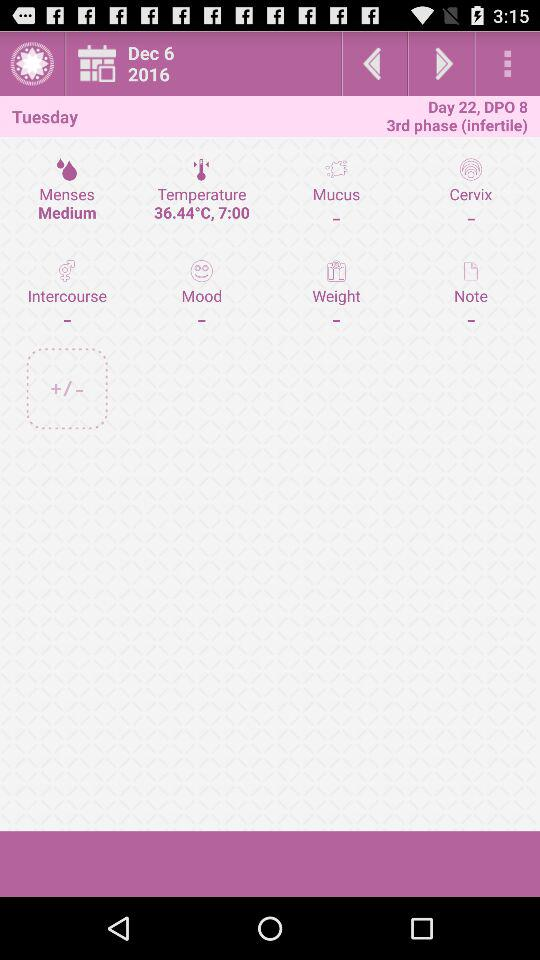At what time was the temperature measured? The temperature was measured at 7:00. 